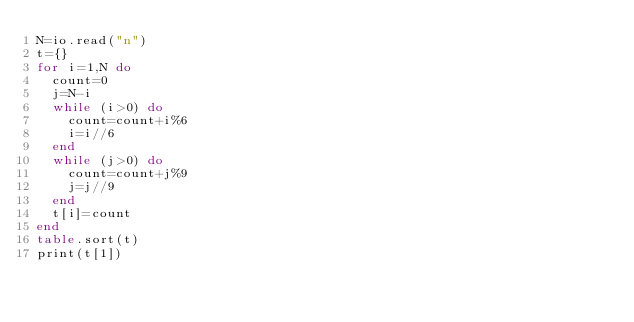Convert code to text. <code><loc_0><loc_0><loc_500><loc_500><_Lua_>N=io.read("n")
t={}
for i=1,N do
  count=0
  j=N-i 
  while (i>0) do
    count=count+i%6
    i=i//6
  end
  while (j>0) do
    count=count+j%9
    j=j//9
  end
  t[i]=count
end
table.sort(t)
print(t[1])</code> 